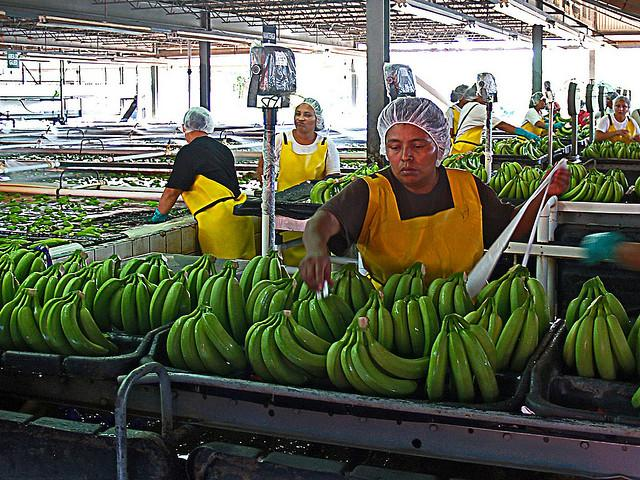What does the hair cap prevent?

Choices:
A) flies
B) dandruff
C) stray hairs
D) distraction stray hairs 